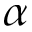<formula> <loc_0><loc_0><loc_500><loc_500>\alpha</formula> 